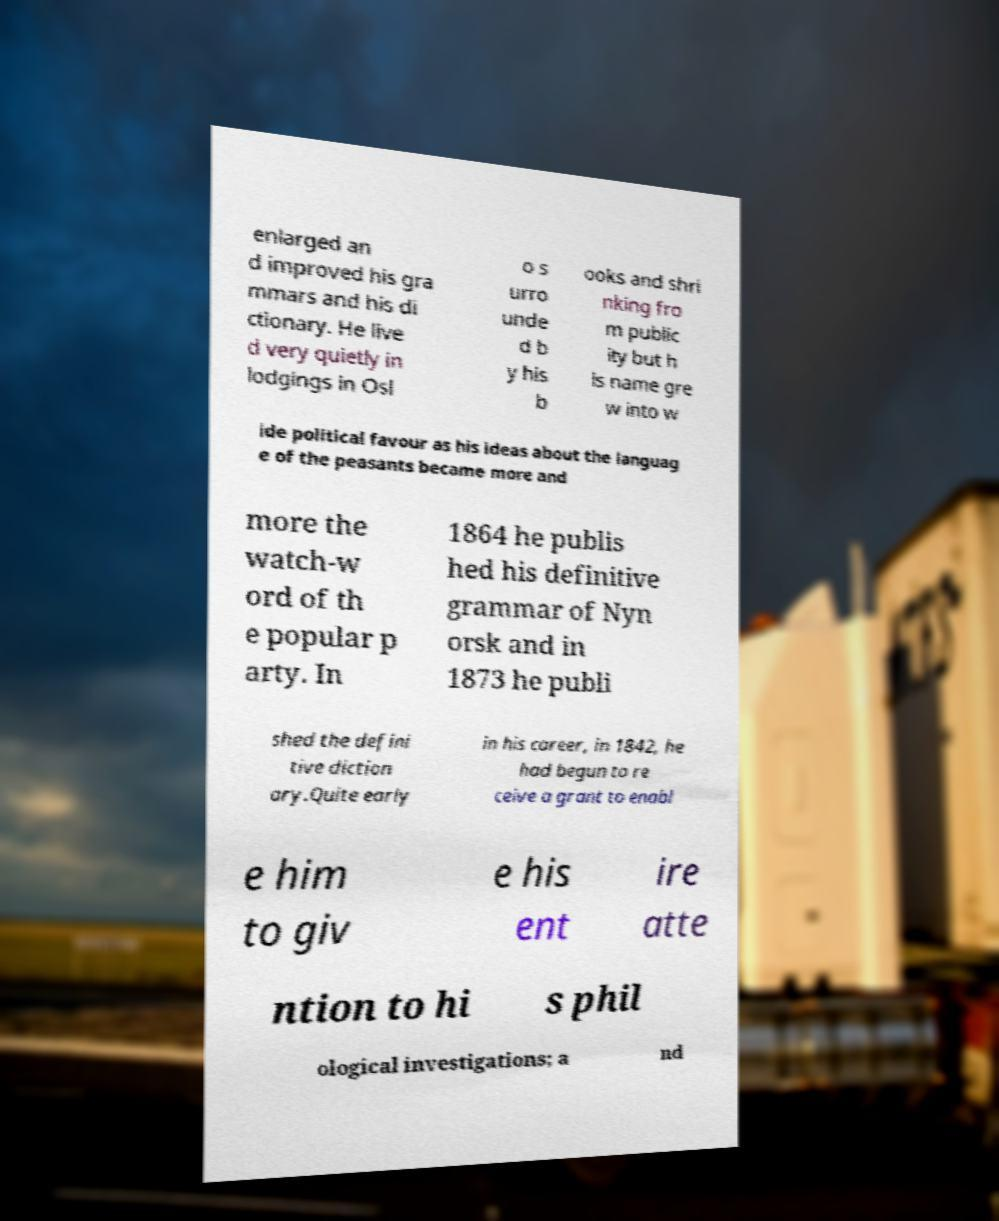What messages or text are displayed in this image? I need them in a readable, typed format. enlarged an d improved his gra mmars and his di ctionary. He live d very quietly in lodgings in Osl o s urro unde d b y his b ooks and shri nking fro m public ity but h is name gre w into w ide political favour as his ideas about the languag e of the peasants became more and more the watch-w ord of th e popular p arty. In 1864 he publis hed his definitive grammar of Nyn orsk and in 1873 he publi shed the defini tive diction ary.Quite early in his career, in 1842, he had begun to re ceive a grant to enabl e him to giv e his ent ire atte ntion to hi s phil ological investigations; a nd 